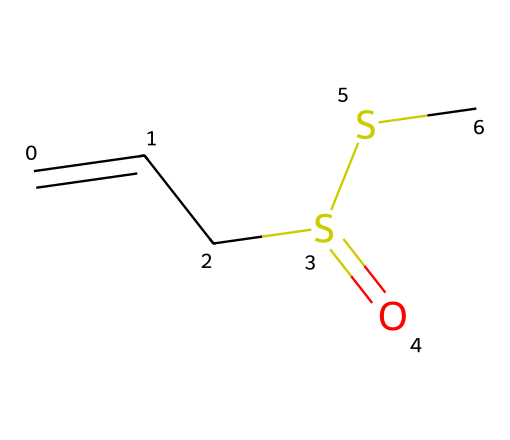What is the molecular formula of allicin? To determine the molecular formula, we can deduce it from the arrangement of atoms in the SMILES representation. The structure contains two carbon atoms from the ethylene group, one sulfur atom from the thiol group, and additional sulfur atoms. Counting all atoms gives us C6H10O3S2.
Answer: C6H10O3S2 How many sulfur atoms are in allicin? By analyzing the SMILES representation, we can identify two sulfur atoms present in the structure as denoted by "S" in the SMILES. Hence, when counting distinct sulfur symbols, we reach the conclusion of two sulfur atoms in total.
Answer: 2 What type of compound is allicin? Allicin is classified as a thiosulfinate due to the presence of the sulfur-sulfur (S–S) linkage along with the thiol group, indicating it falls under the broader category of sulfur-containing compounds.
Answer: thiosulfinate Which functional group is present in allicin? Examining the structure, we can recognize the sulfoxide functional group derived from the presence of a sulfur atom bonded to an oxygen atom. This is indicative of the thiosulfinate nature of allicin.
Answer: sulfoxide What is the primary property of allicin that offers health benefits? Allicin's primary health benefit comes from its property as an antimicrobial agent, which can be attributed to its ability to react with various substances in biological environments, thus making it beneficial for health purposes.
Answer: antimicrobial agent What type of bond connects the sulfur atoms in allicin? Analyzing the SMILES structure shows that the sulfur atoms are connected by a single bond, as reflected by their spatial relationship in the molecular configuration, thus indicating a single bond connection between the sulfur atoms.
Answer: single bond 